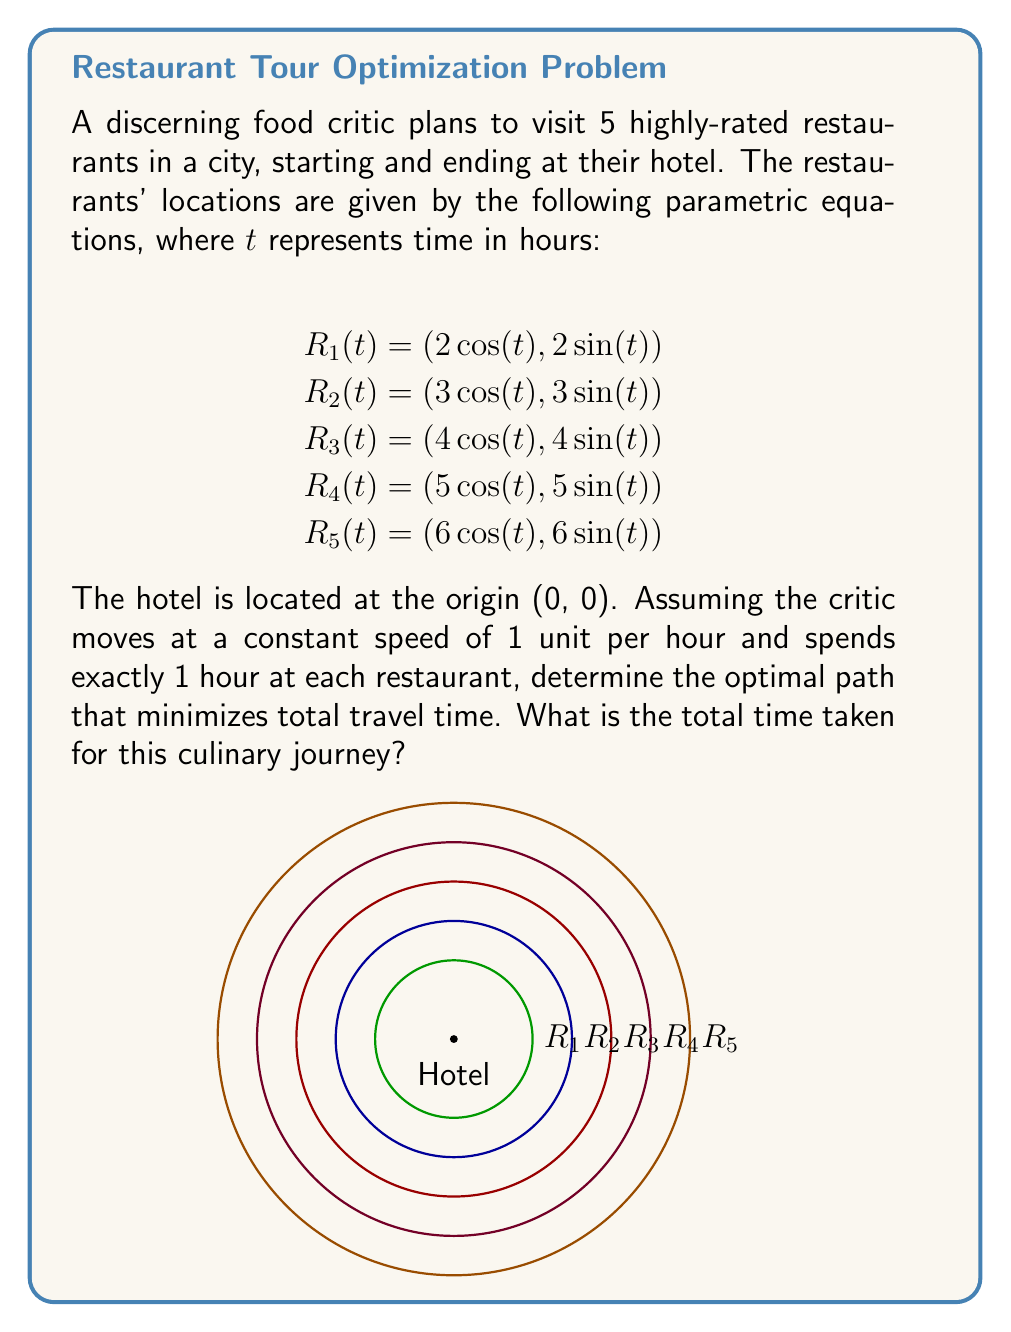Show me your answer to this math problem. To find the optimal path, we need to minimize the total travel time between restaurants. The key observation is that the restaurants are arranged in concentric circles around the hotel.

Step 1: Optimal order of visits
The optimal path is to visit the restaurants in order of increasing distance from the hotel. This minimizes the travel time between consecutive restaurants.

Order: Hotel → R1 → R2 → R3 → R4 → R5 → Hotel

Step 2: Calculate travel times
- Hotel to R1: 2 units
- R1 to R2: 1 unit (3 - 2)
- R2 to R3: 1 unit (4 - 3)
- R3 to R4: 1 unit (5 - 4)
- R4 to R5: 1 unit (6 - 5)
- R5 to Hotel: 6 units

Step 3: Sum up travel times
Total travel time = 2 + 1 + 1 + 1 + 1 + 6 = 12 hours

Step 4: Add dining time
Time spent at restaurants = 5 × 1 hour = 5 hours

Step 5: Calculate total time
Total time = Travel time + Dining time
           = 12 + 5 = 17 hours
Answer: 17 hours 